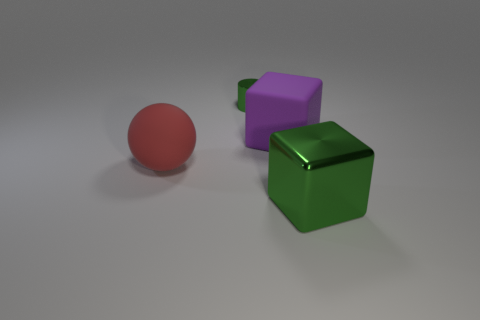Add 2 purple objects. How many objects exist? 6 Subtract all gray cylinders. How many purple cubes are left? 1 Subtract all green cubes. How many cubes are left? 1 Subtract 0 gray cylinders. How many objects are left? 4 Subtract all balls. How many objects are left? 3 Subtract 1 cylinders. How many cylinders are left? 0 Subtract all gray spheres. Subtract all brown blocks. How many spheres are left? 1 Subtract all tiny brown metal cylinders. Subtract all large purple rubber cubes. How many objects are left? 3 Add 1 green shiny things. How many green shiny things are left? 3 Add 2 big green blocks. How many big green blocks exist? 3 